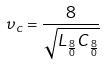<formula> <loc_0><loc_0><loc_500><loc_500>\upsilon _ { c } = \frac { 8 } { \sqrt { L _ { \frac { 8 } { 0 } } C _ { \frac { 8 } { 0 } } } }</formula> 